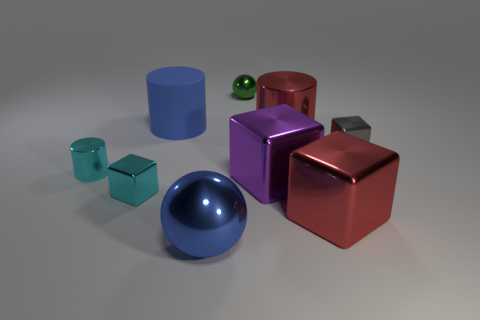Subtract all blue cylinders. How many cylinders are left? 2 Subtract all blue cylinders. How many cylinders are left? 2 Subtract all blocks. How many objects are left? 5 Subtract all brown spheres. How many gray blocks are left? 1 Add 9 large red shiny cylinders. How many large red shiny cylinders exist? 10 Subtract 0 gray cylinders. How many objects are left? 9 Subtract 2 blocks. How many blocks are left? 2 Subtract all purple cylinders. Subtract all gray balls. How many cylinders are left? 3 Subtract all small cyan metallic objects. Subtract all small cyan cylinders. How many objects are left? 6 Add 6 cyan metallic things. How many cyan metallic things are left? 8 